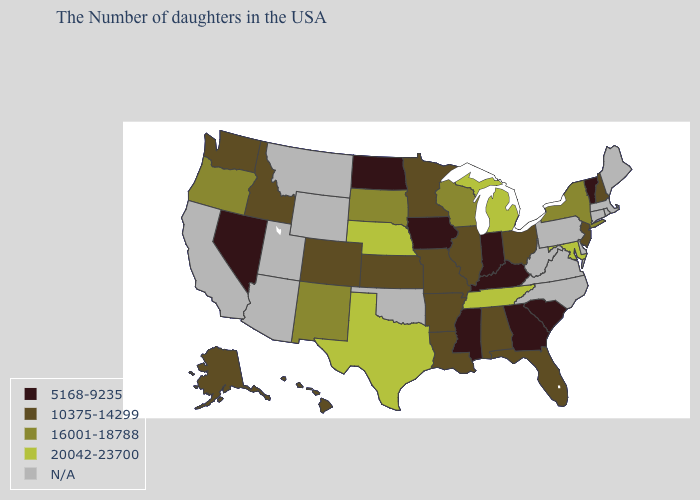Name the states that have a value in the range 16001-18788?
Give a very brief answer. New York, Wisconsin, South Dakota, New Mexico, Oregon. Among the states that border Nevada , does Idaho have the lowest value?
Concise answer only. Yes. Name the states that have a value in the range 20042-23700?
Short answer required. Maryland, Michigan, Tennessee, Nebraska, Texas. Does Mississippi have the highest value in the South?
Write a very short answer. No. Among the states that border West Virginia , does Kentucky have the lowest value?
Write a very short answer. Yes. Does Florida have the lowest value in the USA?
Quick response, please. No. Name the states that have a value in the range 10375-14299?
Keep it brief. New Hampshire, New Jersey, Ohio, Florida, Alabama, Illinois, Louisiana, Missouri, Arkansas, Minnesota, Kansas, Colorado, Idaho, Washington, Alaska, Hawaii. Name the states that have a value in the range N/A?
Quick response, please. Maine, Massachusetts, Rhode Island, Connecticut, Delaware, Pennsylvania, Virginia, North Carolina, West Virginia, Oklahoma, Wyoming, Utah, Montana, Arizona, California. What is the value of Louisiana?
Answer briefly. 10375-14299. Name the states that have a value in the range N/A?
Short answer required. Maine, Massachusetts, Rhode Island, Connecticut, Delaware, Pennsylvania, Virginia, North Carolina, West Virginia, Oklahoma, Wyoming, Utah, Montana, Arizona, California. What is the value of Tennessee?
Short answer required. 20042-23700. Among the states that border Florida , does Georgia have the highest value?
Answer briefly. No. Does New Mexico have the lowest value in the USA?
Quick response, please. No. 